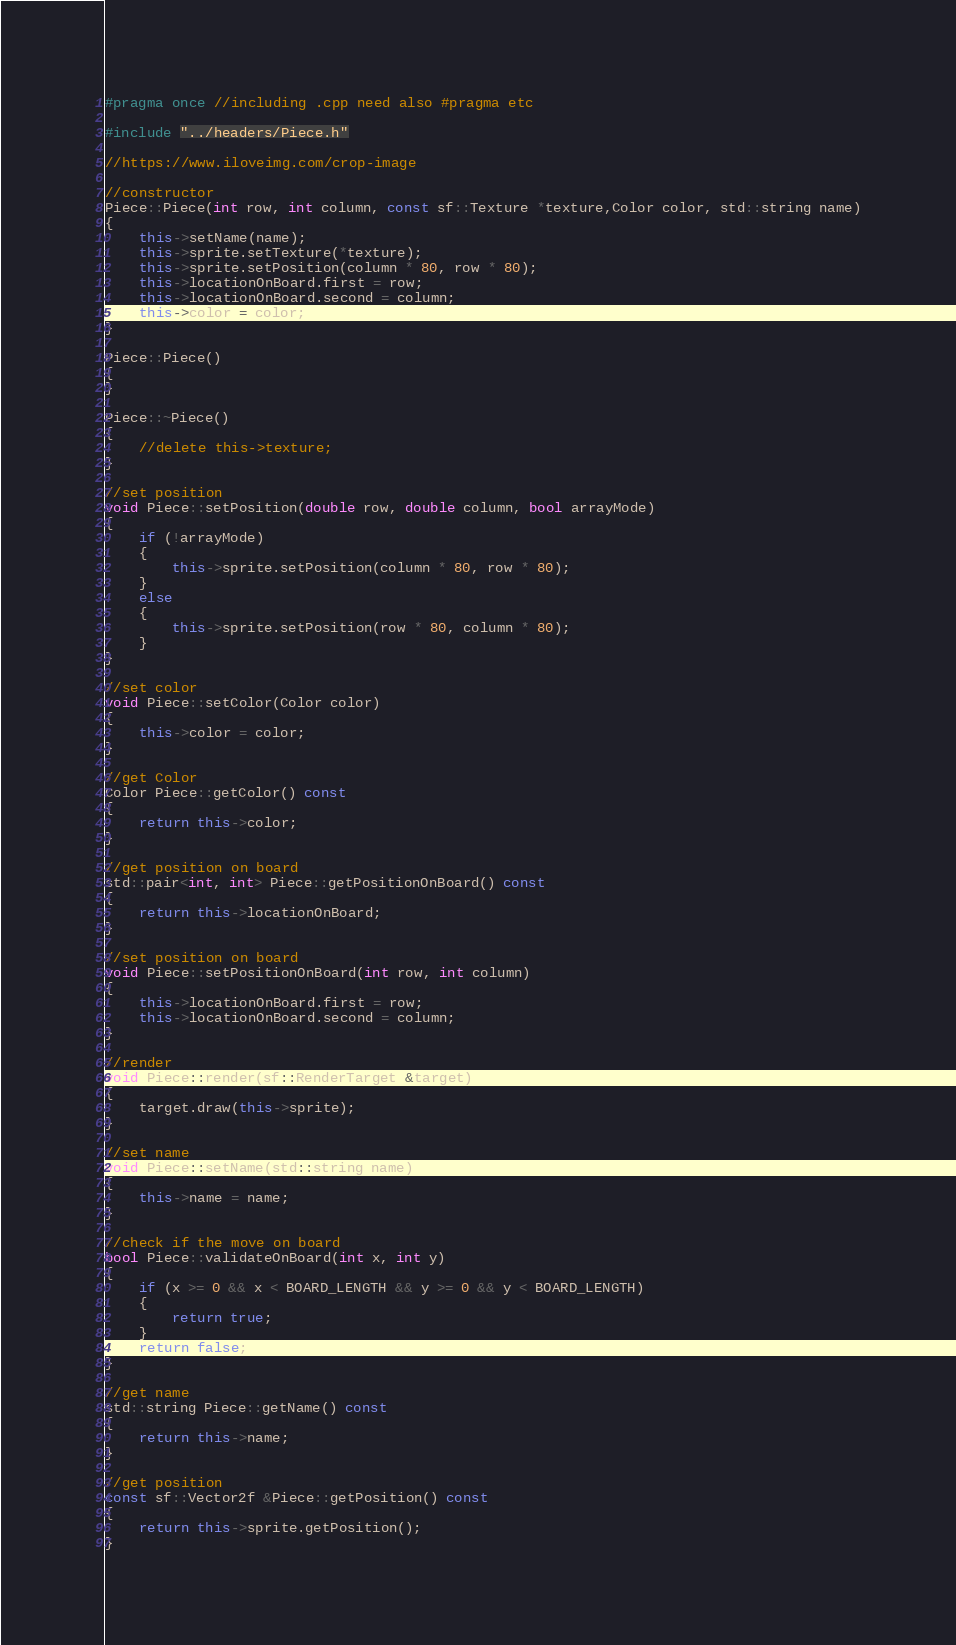<code> <loc_0><loc_0><loc_500><loc_500><_C++_>
#pragma once //including .cpp need also #pragma etc

#include "../headers/Piece.h"

//https://www.iloveimg.com/crop-image

//constructor
Piece::Piece(int row, int column, const sf::Texture *texture,Color color, std::string name)
{
    this->setName(name);
    this->sprite.setTexture(*texture);
    this->sprite.setPosition(column * 80, row * 80);
    this->locationOnBoard.first = row;
    this->locationOnBoard.second = column;
    this->color = color;
}

Piece::Piece()
{
}

Piece::~Piece()
{
    //delete this->texture;
}

//set position
void Piece::setPosition(double row, double column, bool arrayMode)
{
    if (!arrayMode)
    {
        this->sprite.setPosition(column * 80, row * 80);
    }
    else
    {
        this->sprite.setPosition(row * 80, column * 80);
    }
}

//set color
void Piece::setColor(Color color)
{
    this->color = color;
}

//get Color
Color Piece::getColor() const
{
    return this->color;
}

//get position on board
std::pair<int, int> Piece::getPositionOnBoard() const
{
    return this->locationOnBoard;
}

//set position on board
void Piece::setPositionOnBoard(int row, int column)
{
    this->locationOnBoard.first = row;
    this->locationOnBoard.second = column;
}

//render
void Piece::render(sf::RenderTarget &target)
{
    target.draw(this->sprite);
}

//set name
void Piece::setName(std::string name)
{
    this->name = name;
}

//check if the move on board
bool Piece::validateOnBoard(int x, int y) 
{
    if (x >= 0 && x < BOARD_LENGTH && y >= 0 && y < BOARD_LENGTH)
    {
        return true;
    }
    return false;
}

//get name
std::string Piece::getName() const
{
    return this->name;
}

//get position
const sf::Vector2f &Piece::getPosition() const
{
    return this->sprite.getPosition();
}</code> 